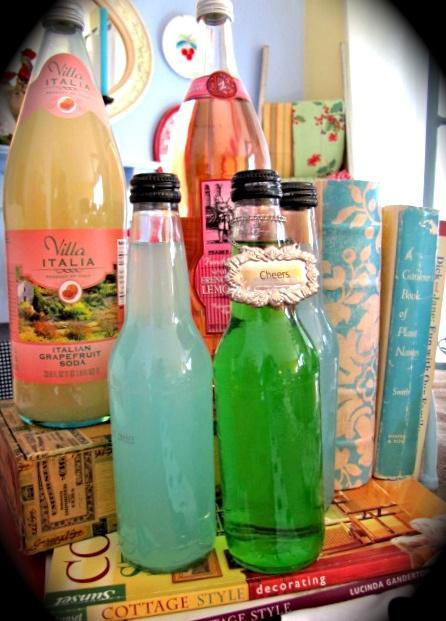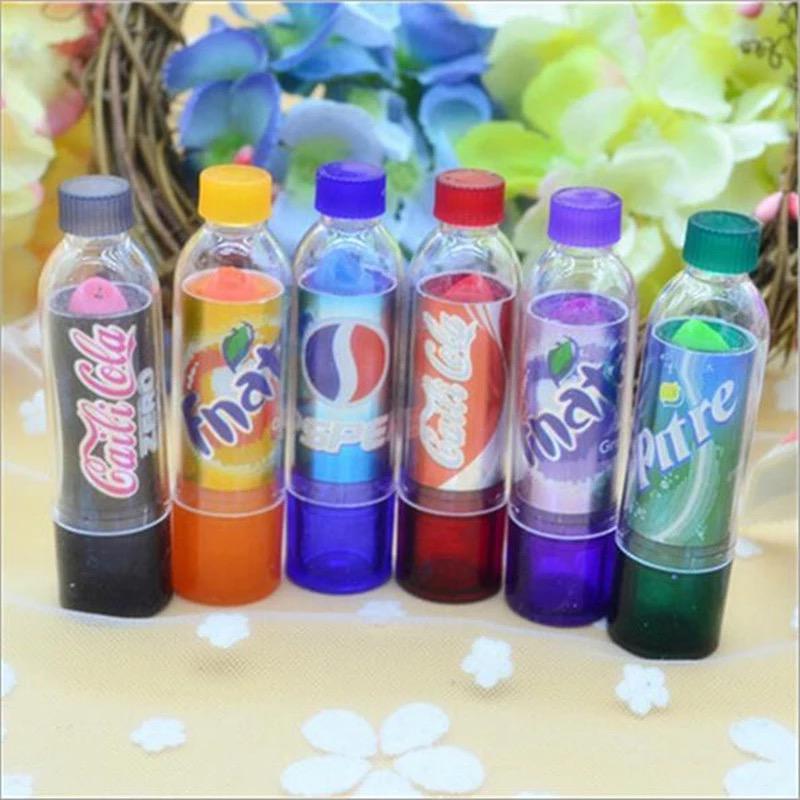The first image is the image on the left, the second image is the image on the right. Considering the images on both sides, is "One of the bottles is tilted and being propped up by another bottle." valid? Answer yes or no. No. The first image is the image on the left, the second image is the image on the right. Assess this claim about the two images: "The right image shows one bottle leaning on an upright bottle, in front of a row of similar bottles shown in different colors.". Correct or not? Answer yes or no. No. 